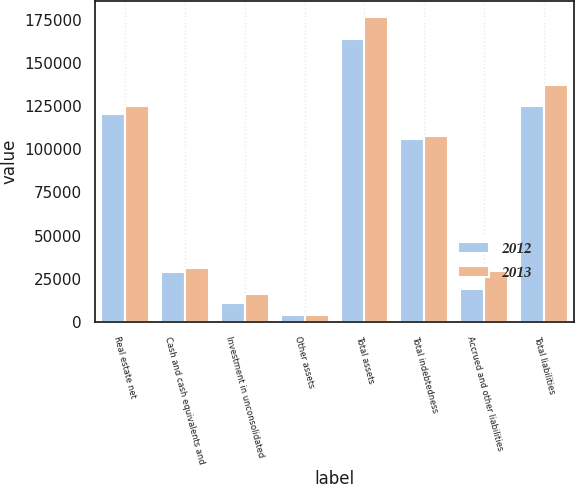Convert chart to OTSL. <chart><loc_0><loc_0><loc_500><loc_500><stacked_bar_chart><ecel><fcel>Real estate net<fcel>Cash and cash equivalents and<fcel>Investment in unconsolidated<fcel>Other assets<fcel>Total assets<fcel>Total indebtedness<fcel>Accrued and other liabilities<fcel>Total liabilities<nl><fcel>2012<fcel>120175<fcel>29046<fcel>10817<fcel>3811<fcel>163849<fcel>106032<fcel>19263<fcel>125295<nl><fcel>2013<fcel>125065<fcel>31558<fcel>15987<fcel>4146<fcel>176756<fcel>107562<fcel>29422<fcel>136984<nl></chart> 